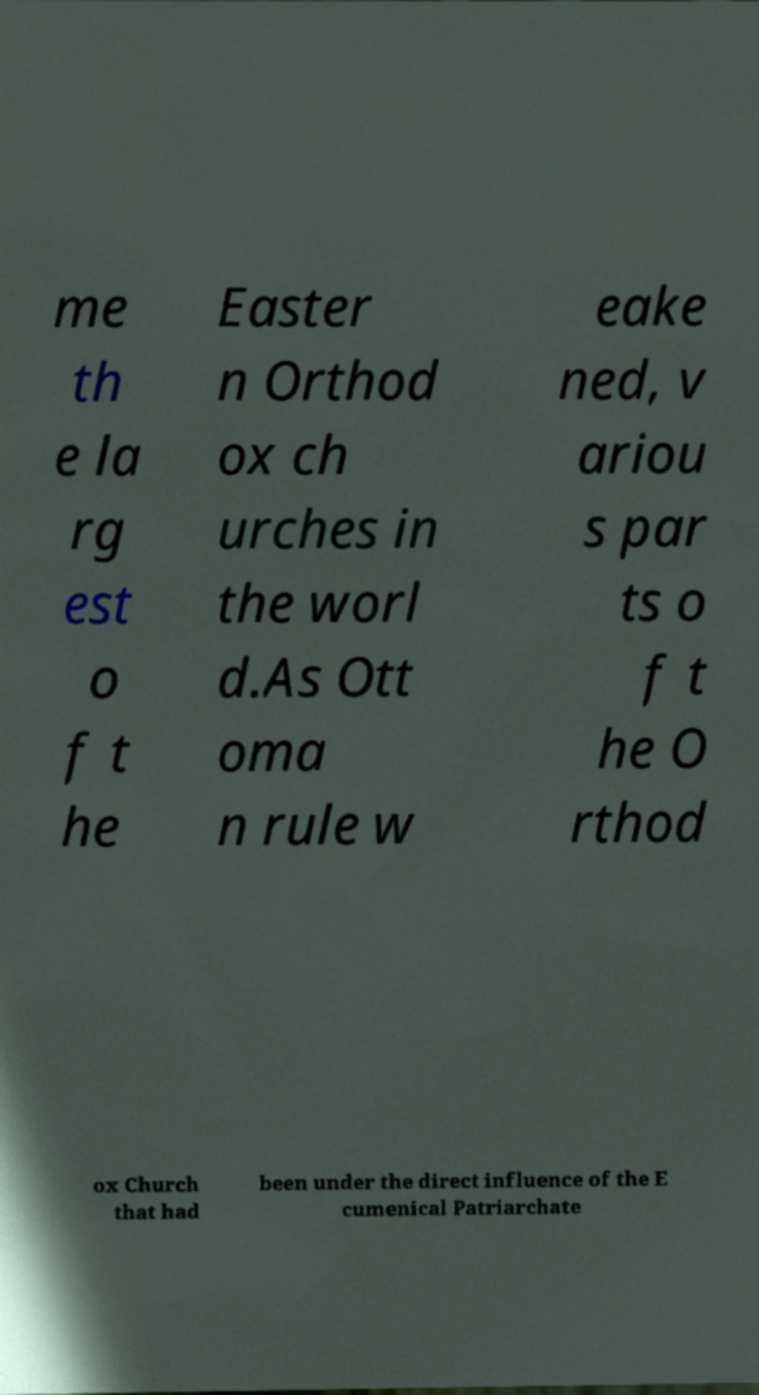Could you assist in decoding the text presented in this image and type it out clearly? me th e la rg est o f t he Easter n Orthod ox ch urches in the worl d.As Ott oma n rule w eake ned, v ariou s par ts o f t he O rthod ox Church that had been under the direct influence of the E cumenical Patriarchate 